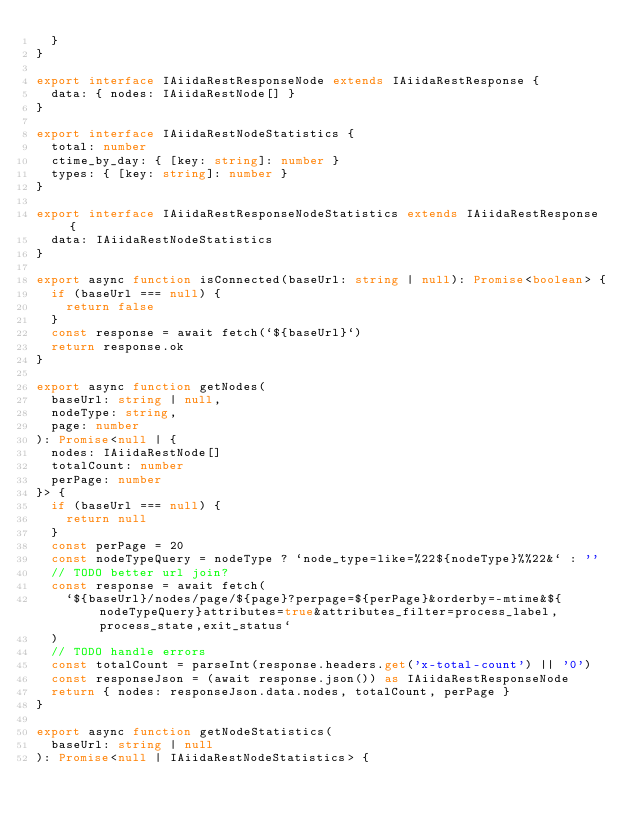Convert code to text. <code><loc_0><loc_0><loc_500><loc_500><_TypeScript_>  }
}

export interface IAiidaRestResponseNode extends IAiidaRestResponse {
  data: { nodes: IAiidaRestNode[] }
}

export interface IAiidaRestNodeStatistics {
  total: number
  ctime_by_day: { [key: string]: number }
  types: { [key: string]: number }
}

export interface IAiidaRestResponseNodeStatistics extends IAiidaRestResponse {
  data: IAiidaRestNodeStatistics
}

export async function isConnected(baseUrl: string | null): Promise<boolean> {
  if (baseUrl === null) {
    return false
  }
  const response = await fetch(`${baseUrl}`)
  return response.ok
}

export async function getNodes(
  baseUrl: string | null,
  nodeType: string,
  page: number
): Promise<null | {
  nodes: IAiidaRestNode[]
  totalCount: number
  perPage: number
}> {
  if (baseUrl === null) {
    return null
  }
  const perPage = 20
  const nodeTypeQuery = nodeType ? `node_type=like=%22${nodeType}%%22&` : ''
  // TODO better url join?
  const response = await fetch(
    `${baseUrl}/nodes/page/${page}?perpage=${perPage}&orderby=-mtime&${nodeTypeQuery}attributes=true&attributes_filter=process_label,process_state,exit_status`
  )
  // TODO handle errors
  const totalCount = parseInt(response.headers.get('x-total-count') || '0')
  const responseJson = (await response.json()) as IAiidaRestResponseNode
  return { nodes: responseJson.data.nodes, totalCount, perPage }
}

export async function getNodeStatistics(
  baseUrl: string | null
): Promise<null | IAiidaRestNodeStatistics> {</code> 